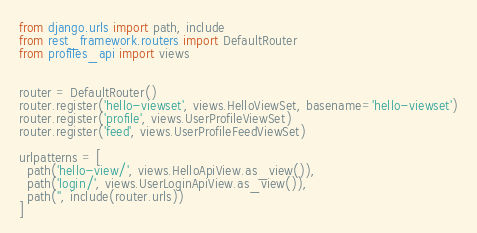Convert code to text. <code><loc_0><loc_0><loc_500><loc_500><_Python_>from django.urls import path, include
from rest_framework.routers import DefaultRouter
from profiles_api import views


router = DefaultRouter()
router.register('hello-viewset', views.HelloViewSet, basename='hello-viewset')
router.register('profile', views.UserProfileViewSet)
router.register('feed', views.UserProfileFeedViewSet)

urlpatterns = [
  path('hello-view/', views.HelloApiView.as_view()),
  path('login/', views.UserLoginApiView.as_view()),
  path('', include(router.urls))
]</code> 